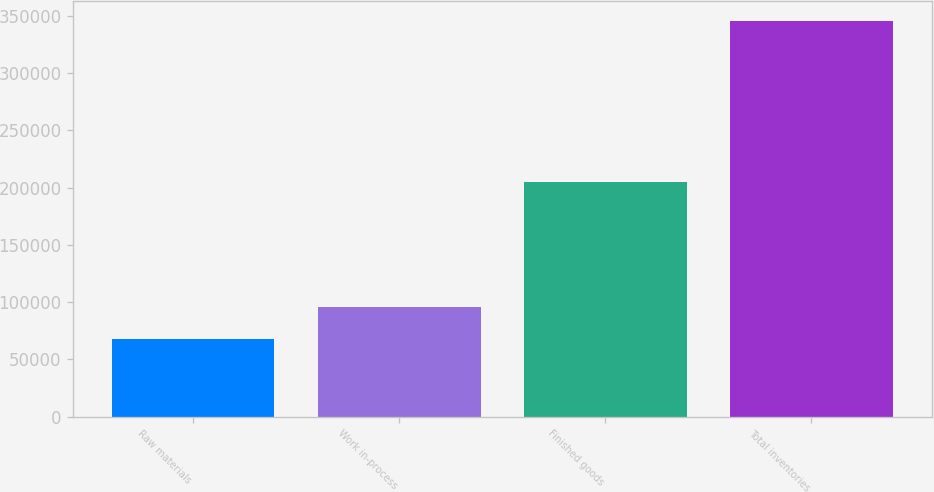Convert chart. <chart><loc_0><loc_0><loc_500><loc_500><bar_chart><fcel>Raw materials<fcel>Work in-process<fcel>Finished goods<fcel>Total inventories<nl><fcel>67880<fcel>95644.5<fcel>204947<fcel>345525<nl></chart> 